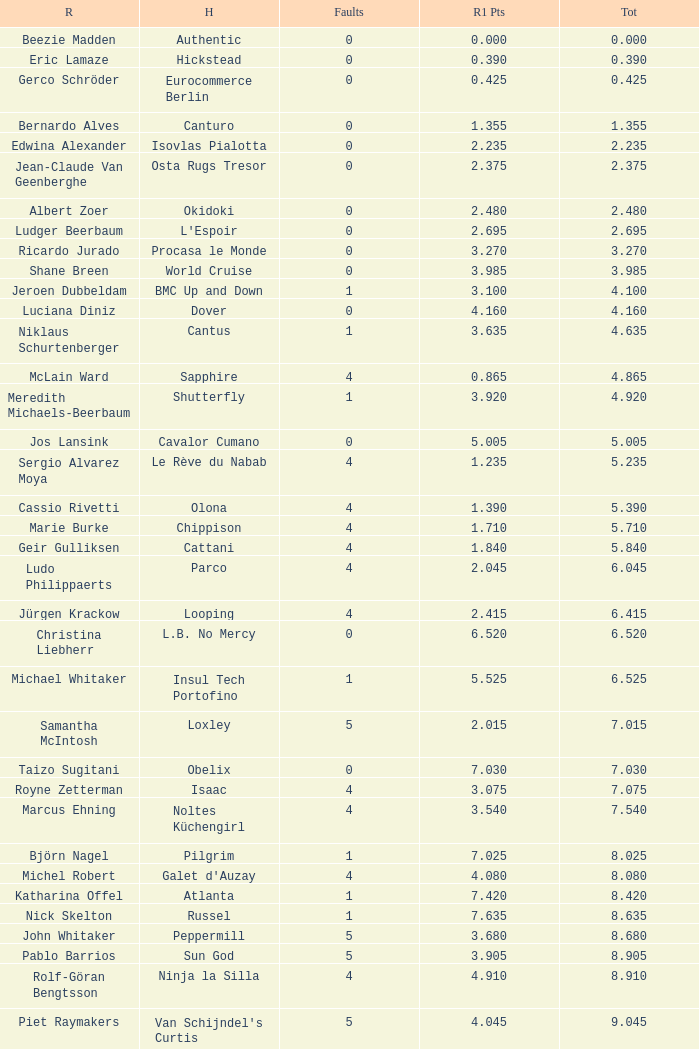Tell me the rider with 18.185 points round 1 Veronika Macanova. 